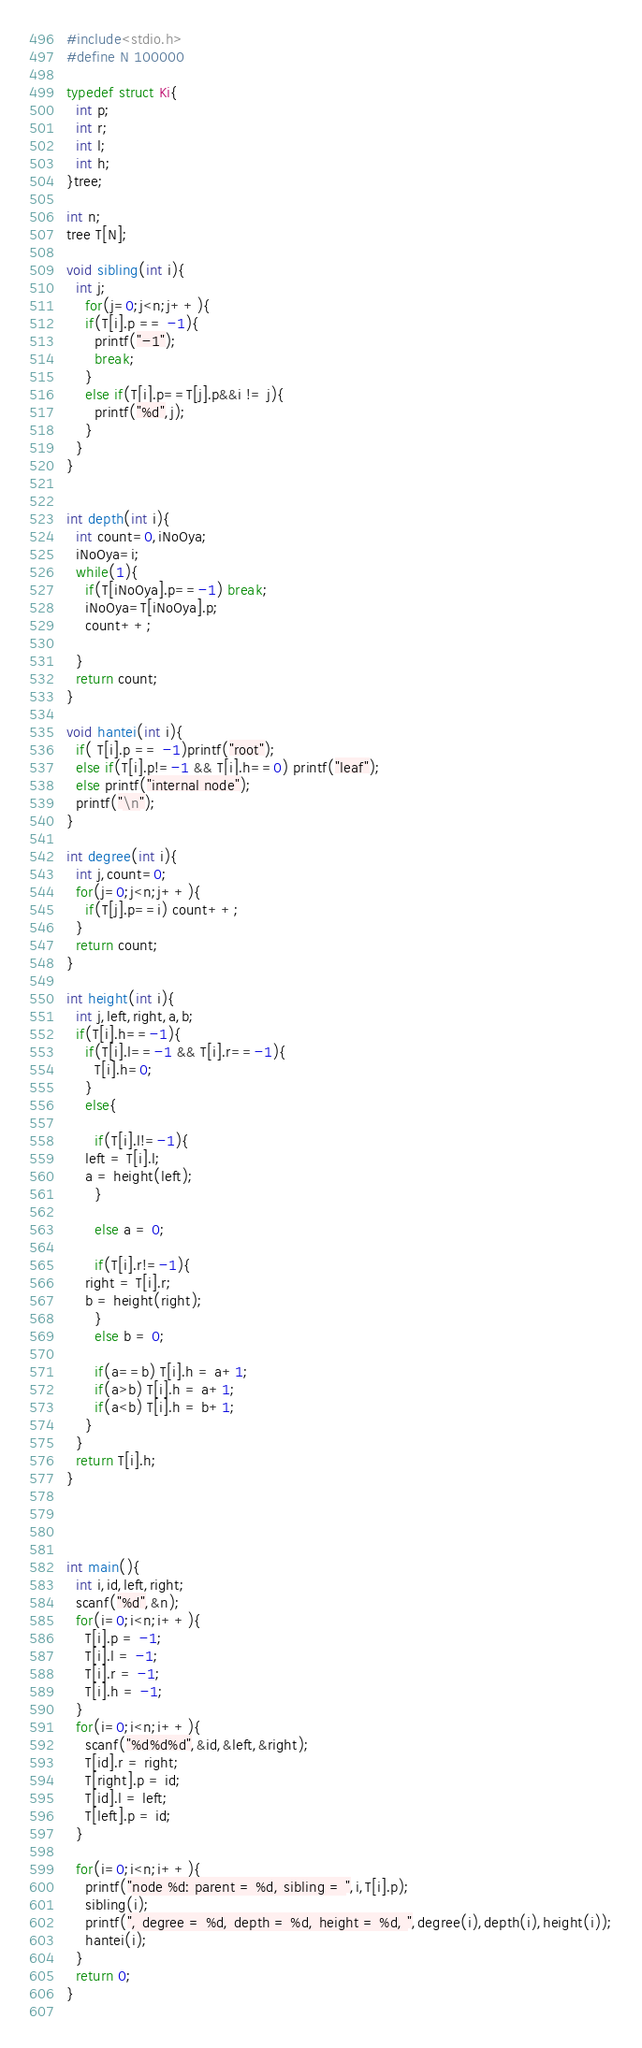<code> <loc_0><loc_0><loc_500><loc_500><_C_>#include<stdio.h>
#define N 100000

typedef struct Ki{
  int p;
  int r;
  int l;
  int h;
}tree;

int n;
tree T[N];

void sibling(int i){
  int j;
    for(j=0;j<n;j++){
    if(T[i].p == -1){
      printf("-1");
      break;
    }
    else if(T[i].p==T[j].p&&i != j){
      printf("%d",j);
    }
  }
}


int depth(int i){
  int count=0,iNoOya;
  iNoOya=i;
  while(1){
    if(T[iNoOya].p==-1) break;
    iNoOya=T[iNoOya].p;
    count++;
    
  }
  return count;
}

void hantei(int i){
  if( T[i].p == -1)printf("root");
  else if(T[i].p!=-1 && T[i].h==0) printf("leaf");
  else printf("internal node");
  printf("\n");
}

int degree(int i){
  int j,count=0;
  for(j=0;j<n;j++){
    if(T[j].p==i) count++;
  }
  return count;
}

int height(int i){
  int j,left,right,a,b;
  if(T[i].h==-1){
    if(T[i].l==-1 && T[i].r==-1){
      T[i].h=0;
    }
    else{
      
      if(T[i].l!=-1){
	left = T[i].l;
	a = height(left);
      }
      
      else a = 0;
      
      if(T[i].r!=-1){
	right = T[i].r;
	b = height(right);
      }
      else b = 0; 
      
      if(a==b) T[i].h = a+1;
      if(a>b) T[i].h = a+1;
      if(a<b) T[i].h = b+1;
    }
  }
  return T[i].h;
}




int main(){
  int i,id,left,right;
  scanf("%d",&n);
  for(i=0;i<n;i++){
    T[i].p = -1;
    T[i].l = -1;
    T[i].r = -1;
    T[i].h = -1;
  }
  for(i=0;i<n;i++){
    scanf("%d%d%d",&id,&left,&right);
    T[id].r = right;
    T[right].p = id;
    T[id].l = left;
    T[left].p = id;
  }
  
  for(i=0;i<n;i++){
    printf("node %d: parent = %d, sibling = ",i,T[i].p);
    sibling(i);
    printf(", degree = %d, depth = %d, height = %d, ",degree(i),depth(i),height(i));
    hantei(i);
  }
  return 0;
}
 </code> 